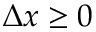<formula> <loc_0><loc_0><loc_500><loc_500>\Delta x \geq 0</formula> 